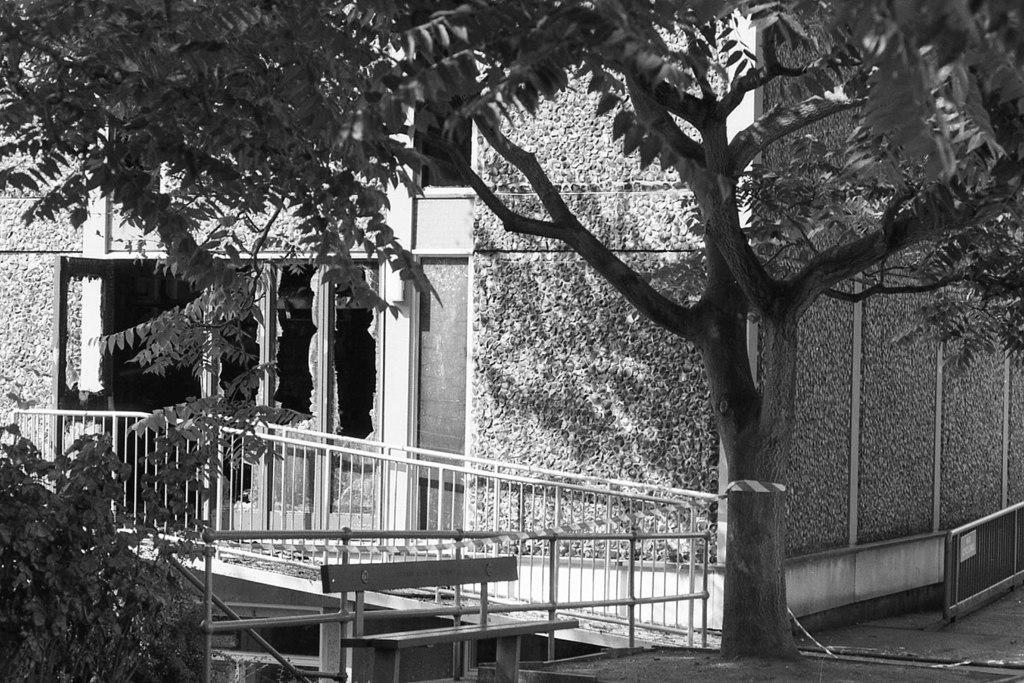In one or two sentences, can you explain what this image depicts? In this image in the front there are trees and there is a railing. In the background there is a building. 